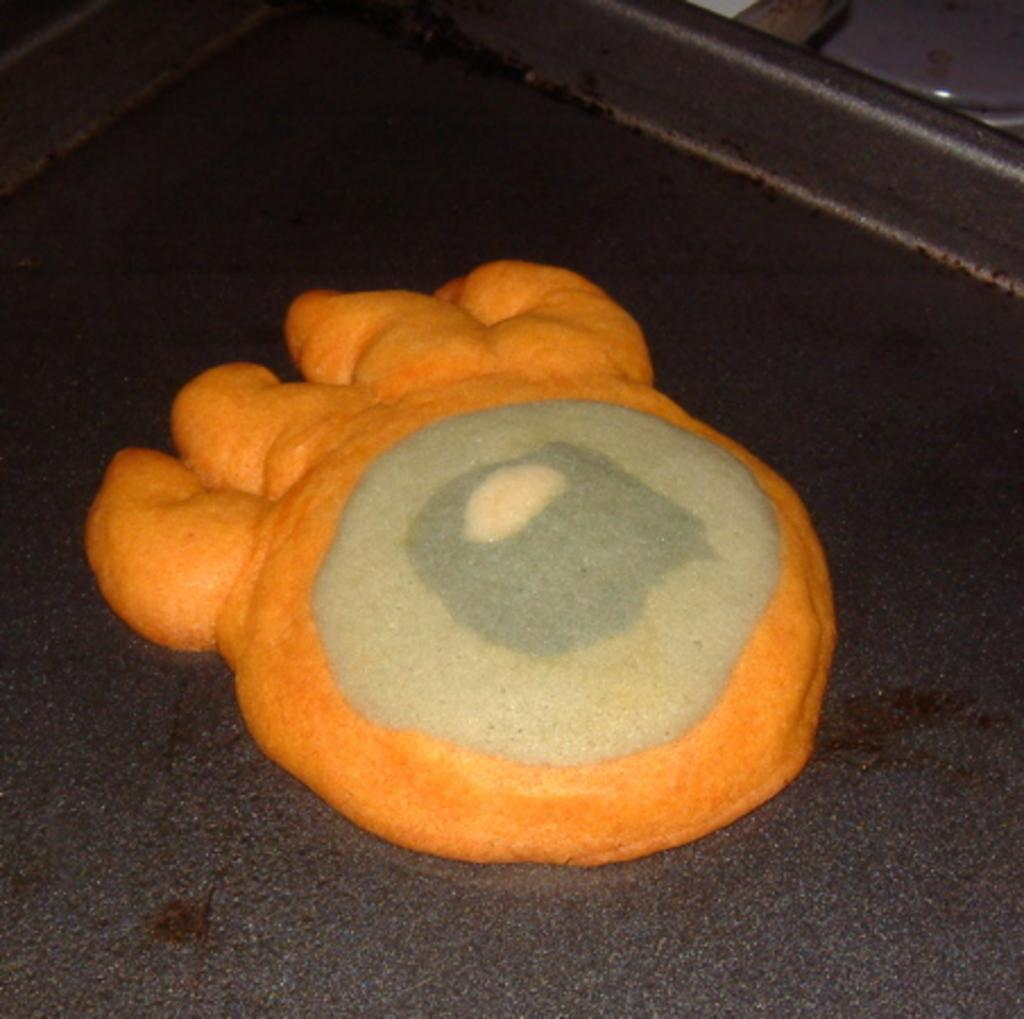What is the main object in the center of the image? There is a table in the center of the image. What can be seen on the table? There is an object on the table, which has orange and cream colors. What is located in the top right side of the image? There is an object in the top right side of the image. How many vacations are planned for the machine in the image? There is no machine present in the image, and therefore no vacations can be planned for it. 